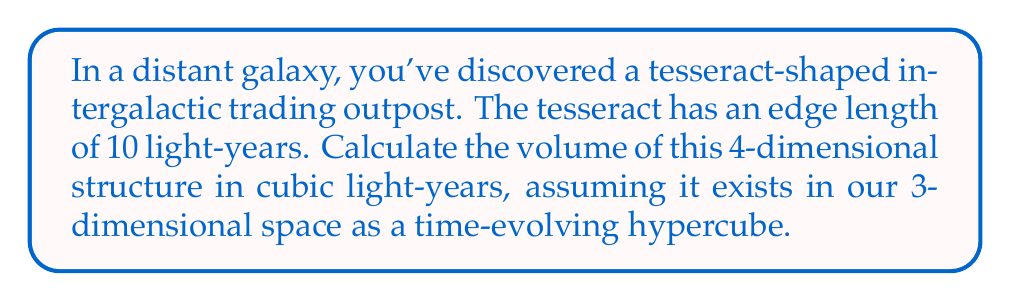Can you answer this question? To solve this problem, let's break it down into steps:

1) A tesseract is a 4-dimensional hypercube. In our 3D space, we can think of it as a cube that evolves over time, creating a 4D object.

2) The volume of a tesseract is calculated using the formula:

   $$V_{tesseract} = a^4$$

   where $a$ is the length of one edge of the tesseract.

3) In this case, we're given that the edge length is 10 light-years. Let's substitute this into our formula:

   $$V_{tesseract} = (10)^4$$

4) Now, let's calculate:

   $$V_{tesseract} = 10 * 10 * 10 * 10 = 10,000$$

5) The units will be light-years to the fourth power (ly^4), as we're dealing with a 4D object.

6) However, since we're asked to consider this in our 3D space, we need to interpret this 4D volume as a 3D volume that changes over time. 

7) We can think of this as the volume of a cube with side length 10 ly, multiplied by a time factor of 10 years:

   $$V_{3D} = 10^3 * 10 = 10,000$$

8) This gives us the same numeric result, but now in units of cubic light-years (ly^3).

Thus, the volume of the tesseract-shaped trading outpost, when considered in our 3D space, is 10,000 cubic light-years.
Answer: 10,000 cubic light-years 